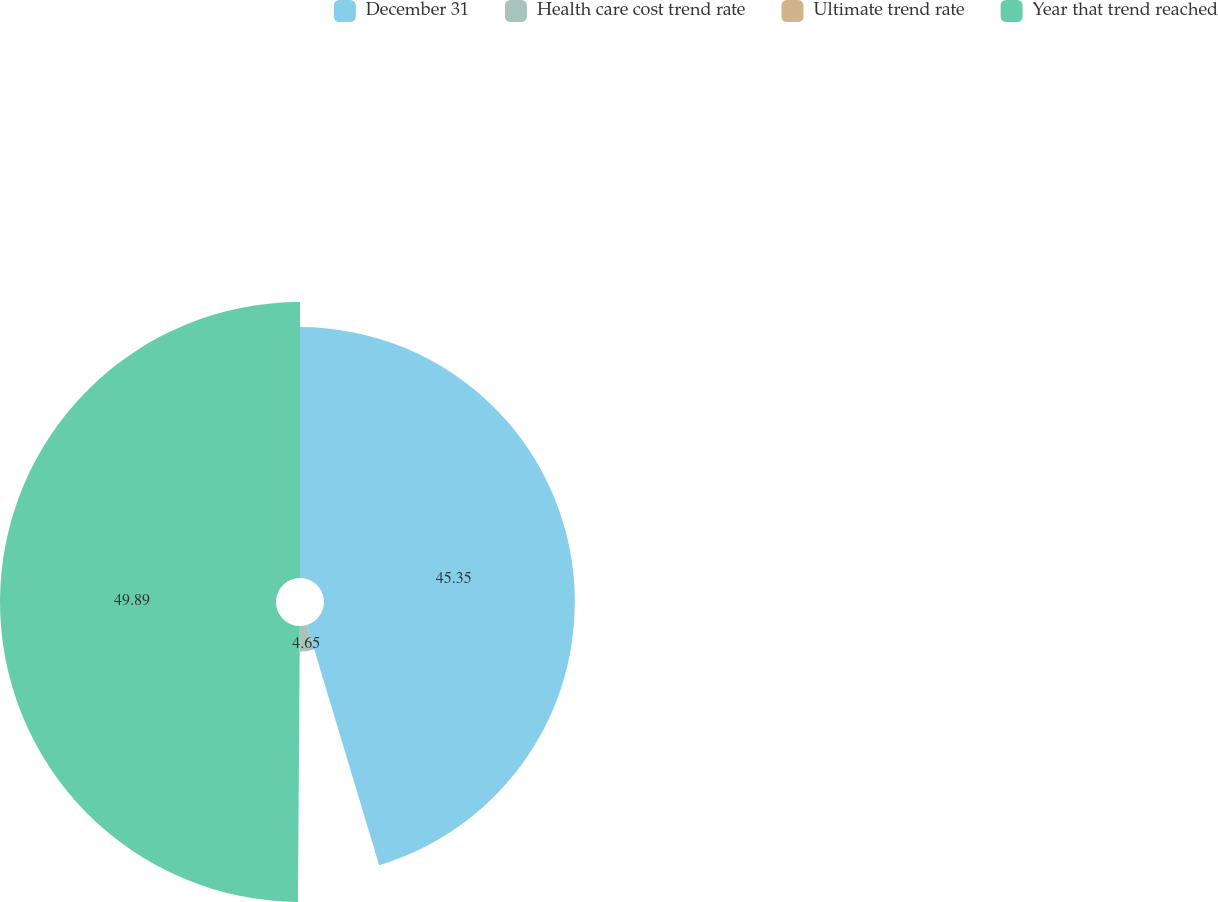Convert chart to OTSL. <chart><loc_0><loc_0><loc_500><loc_500><pie_chart><fcel>December 31<fcel>Health care cost trend rate<fcel>Ultimate trend rate<fcel>Year that trend reached<nl><fcel>45.35%<fcel>4.65%<fcel>0.11%<fcel>49.89%<nl></chart> 